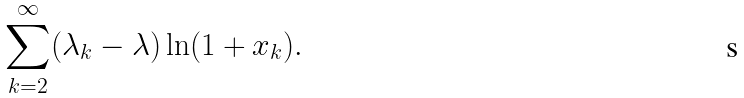<formula> <loc_0><loc_0><loc_500><loc_500>\sum _ { k = 2 } ^ { \infty } ( \lambda _ { k } - \lambda ) \ln ( 1 + x _ { k } ) .</formula> 